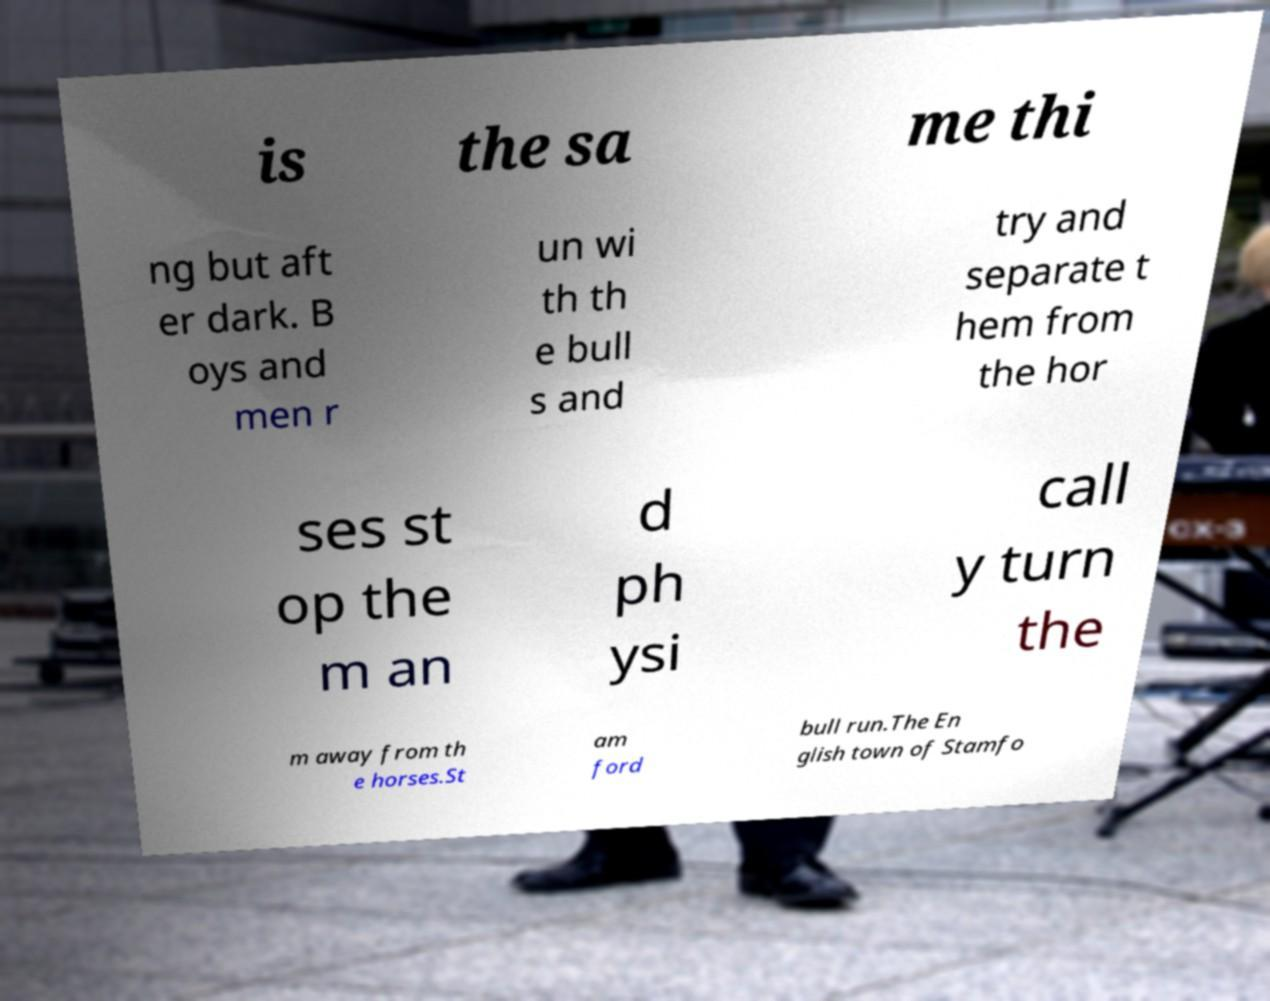Please read and relay the text visible in this image. What does it say? is the sa me thi ng but aft er dark. B oys and men r un wi th th e bull s and try and separate t hem from the hor ses st op the m an d ph ysi call y turn the m away from th e horses.St am ford bull run.The En glish town of Stamfo 